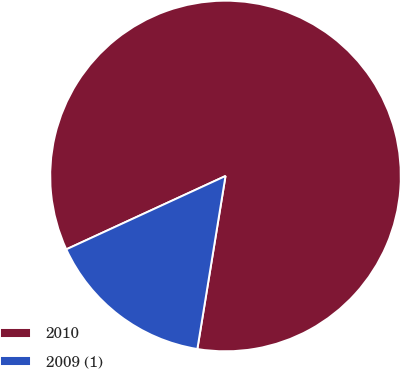Convert chart to OTSL. <chart><loc_0><loc_0><loc_500><loc_500><pie_chart><fcel>2010<fcel>2009 (1)<nl><fcel>84.44%<fcel>15.56%<nl></chart> 